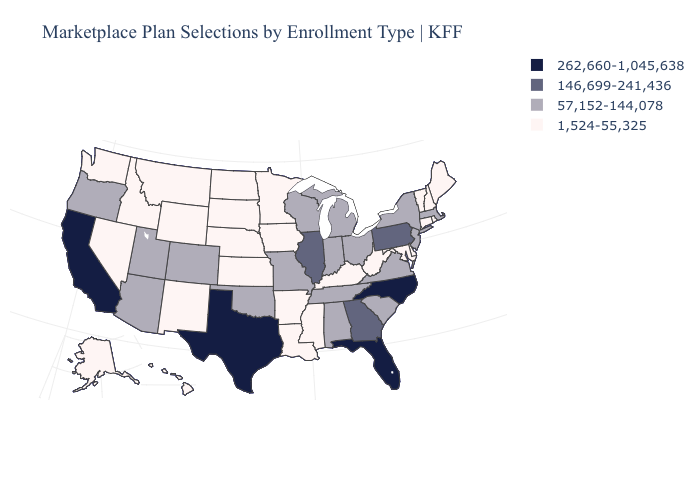What is the highest value in states that border Washington?
Write a very short answer. 57,152-144,078. Is the legend a continuous bar?
Concise answer only. No. Among the states that border Kansas , does Missouri have the lowest value?
Concise answer only. No. Among the states that border California , which have the highest value?
Be succinct. Arizona, Oregon. What is the value of Illinois?
Give a very brief answer. 146,699-241,436. Among the states that border Nevada , does Utah have the lowest value?
Write a very short answer. No. Among the states that border North Carolina , which have the highest value?
Keep it brief. Georgia. Is the legend a continuous bar?
Short answer required. No. Name the states that have a value in the range 146,699-241,436?
Short answer required. Georgia, Illinois, Pennsylvania. Among the states that border Florida , does Alabama have the highest value?
Give a very brief answer. No. Name the states that have a value in the range 57,152-144,078?
Short answer required. Alabama, Arizona, Colorado, Indiana, Massachusetts, Michigan, Missouri, New Jersey, New York, Ohio, Oklahoma, Oregon, South Carolina, Tennessee, Utah, Virginia, Wisconsin. Which states hav the highest value in the Northeast?
Keep it brief. Pennsylvania. What is the highest value in states that border Colorado?
Short answer required. 57,152-144,078. Does Maryland have the lowest value in the South?
Be succinct. Yes. Name the states that have a value in the range 262,660-1,045,638?
Keep it brief. California, Florida, North Carolina, Texas. 